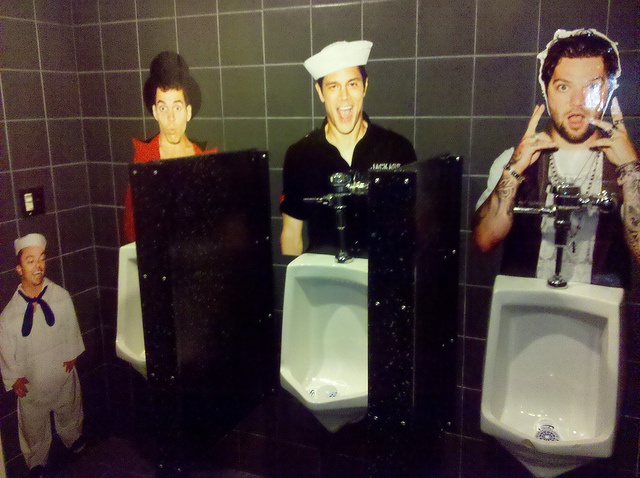Describe the objects in this image and their specific colors. I can see toilet in olive, darkgray, gray, and beige tones, sink in olive, darkgray, gray, and beige tones, people in olive, black, khaki, beige, and tan tones, toilet in olive, darkgray, beige, and black tones, and people in olive, gray, black, and maroon tones in this image. 